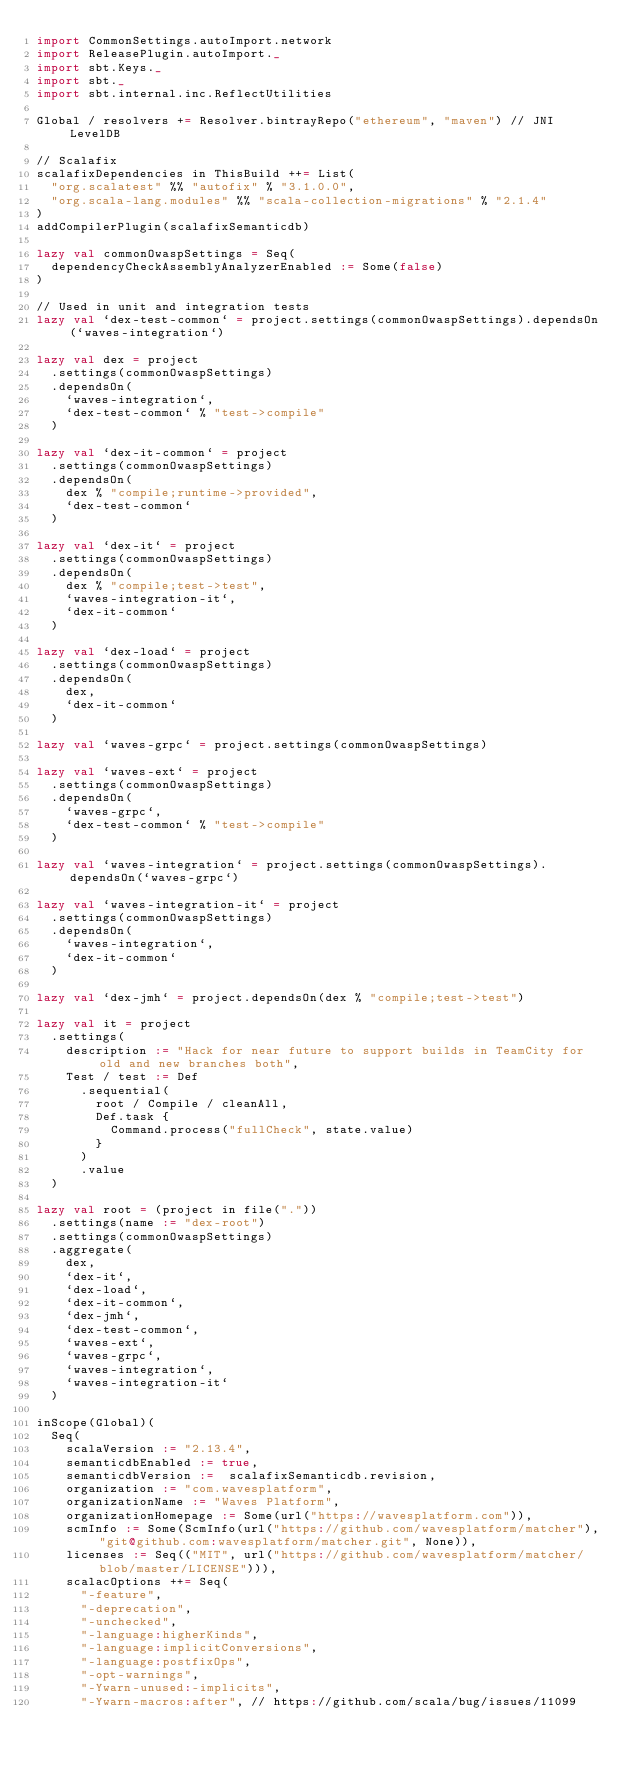Convert code to text. <code><loc_0><loc_0><loc_500><loc_500><_Scala_>import CommonSettings.autoImport.network
import ReleasePlugin.autoImport._
import sbt.Keys._
import sbt._
import sbt.internal.inc.ReflectUtilities

Global / resolvers += Resolver.bintrayRepo("ethereum", "maven") // JNI LevelDB

// Scalafix
scalafixDependencies in ThisBuild ++= List(
  "org.scalatest" %% "autofix" % "3.1.0.0",
  "org.scala-lang.modules" %% "scala-collection-migrations" % "2.1.4"
)
addCompilerPlugin(scalafixSemanticdb)

lazy val commonOwaspSettings = Seq(
  dependencyCheckAssemblyAnalyzerEnabled := Some(false)
)

// Used in unit and integration tests
lazy val `dex-test-common` = project.settings(commonOwaspSettings).dependsOn(`waves-integration`)

lazy val dex = project
  .settings(commonOwaspSettings)
  .dependsOn(
    `waves-integration`,
    `dex-test-common` % "test->compile"
  )

lazy val `dex-it-common` = project
  .settings(commonOwaspSettings)
  .dependsOn(
    dex % "compile;runtime->provided",
    `dex-test-common`
  )

lazy val `dex-it` = project
  .settings(commonOwaspSettings)
  .dependsOn(
    dex % "compile;test->test",
    `waves-integration-it`,
    `dex-it-common`
  )

lazy val `dex-load` = project
  .settings(commonOwaspSettings)
  .dependsOn(
    dex,
    `dex-it-common`
  )

lazy val `waves-grpc` = project.settings(commonOwaspSettings)

lazy val `waves-ext` = project
  .settings(commonOwaspSettings)
  .dependsOn(
    `waves-grpc`,
    `dex-test-common` % "test->compile"
  )

lazy val `waves-integration` = project.settings(commonOwaspSettings).dependsOn(`waves-grpc`)

lazy val `waves-integration-it` = project
  .settings(commonOwaspSettings)
  .dependsOn(
    `waves-integration`,
    `dex-it-common`
  )

lazy val `dex-jmh` = project.dependsOn(dex % "compile;test->test")

lazy val it = project
  .settings(
    description := "Hack for near future to support builds in TeamCity for old and new branches both",
    Test / test := Def
      .sequential(
        root / Compile / cleanAll,
        Def.task {
          Command.process("fullCheck", state.value)
        }
      )
      .value
  )

lazy val root = (project in file("."))
  .settings(name := "dex-root")
  .settings(commonOwaspSettings)
  .aggregate(
    dex,
    `dex-it`,
    `dex-load`,
    `dex-it-common`,
    `dex-jmh`,
    `dex-test-common`,
    `waves-ext`,
    `waves-grpc`,
    `waves-integration`,
    `waves-integration-it`
  )

inScope(Global)(
  Seq(
    scalaVersion := "2.13.4",
    semanticdbEnabled := true,
    semanticdbVersion :=  scalafixSemanticdb.revision,
    organization := "com.wavesplatform",
    organizationName := "Waves Platform",
    organizationHomepage := Some(url("https://wavesplatform.com")),
    scmInfo := Some(ScmInfo(url("https://github.com/wavesplatform/matcher"), "git@github.com:wavesplatform/matcher.git", None)),
    licenses := Seq(("MIT", url("https://github.com/wavesplatform/matcher/blob/master/LICENSE"))),
    scalacOptions ++= Seq(
      "-feature",
      "-deprecation",
      "-unchecked",
      "-language:higherKinds",
      "-language:implicitConversions",
      "-language:postfixOps",
      "-opt-warnings",
      "-Ywarn-unused:-implicits",
      "-Ywarn-macros:after", // https://github.com/scala/bug/issues/11099</code> 